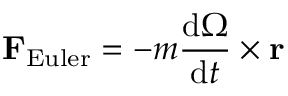<formula> <loc_0><loc_0><loc_500><loc_500>F _ { E u l e r } = - m { \frac { d { \Omega } } { d t } } \times r</formula> 